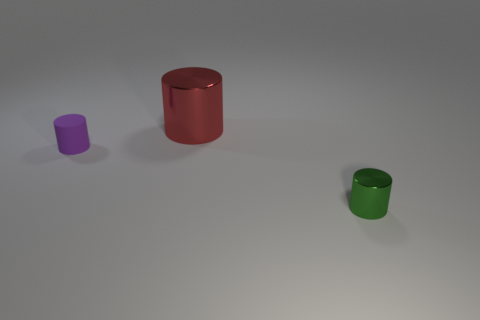There is a shiny cylinder that is in front of the purple cylinder; is it the same size as the big red metal thing?
Provide a short and direct response. No. How many other objects are there of the same material as the large cylinder?
Offer a very short reply. 1. Are there an equal number of tiny purple rubber things behind the purple cylinder and large objects that are in front of the big red shiny object?
Provide a short and direct response. Yes. The cylinder on the right side of the shiny object behind the tiny object behind the small green cylinder is what color?
Your answer should be compact. Green. What shape is the metallic thing left of the small green cylinder?
Give a very brief answer. Cylinder. What shape is the red thing that is the same material as the green cylinder?
Provide a succinct answer. Cylinder. What number of red cylinders are on the left side of the large red cylinder?
Offer a very short reply. 0. Are there an equal number of tiny green things that are behind the purple rubber object and big red metallic cylinders?
Your answer should be compact. No. Does the green cylinder have the same material as the large red cylinder?
Ensure brevity in your answer.  Yes. What size is the cylinder that is right of the matte cylinder and in front of the big red metal cylinder?
Provide a short and direct response. Small. 